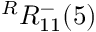Convert formula to latex. <formula><loc_0><loc_0><loc_500><loc_500>{ } ^ { R } { R } _ { 1 { 1 } } ^ { - } ( { 5 } )</formula> 